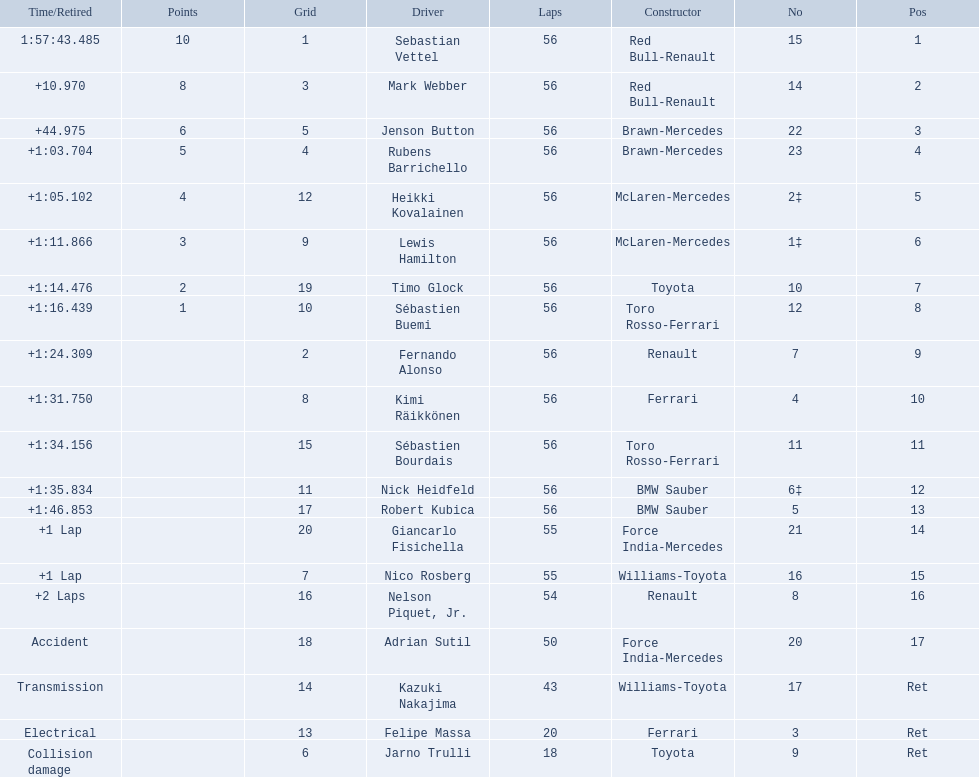Who were all of the drivers in the 2009 chinese grand prix? Sebastian Vettel, Mark Webber, Jenson Button, Rubens Barrichello, Heikki Kovalainen, Lewis Hamilton, Timo Glock, Sébastien Buemi, Fernando Alonso, Kimi Räikkönen, Sébastien Bourdais, Nick Heidfeld, Robert Kubica, Giancarlo Fisichella, Nico Rosberg, Nelson Piquet, Jr., Adrian Sutil, Kazuki Nakajima, Felipe Massa, Jarno Trulli. And what were their finishing times? 1:57:43.485, +10.970, +44.975, +1:03.704, +1:05.102, +1:11.866, +1:14.476, +1:16.439, +1:24.309, +1:31.750, +1:34.156, +1:35.834, +1:46.853, +1 Lap, +1 Lap, +2 Laps, Accident, Transmission, Electrical, Collision damage. Which player faced collision damage and retired from the race? Jarno Trulli. 